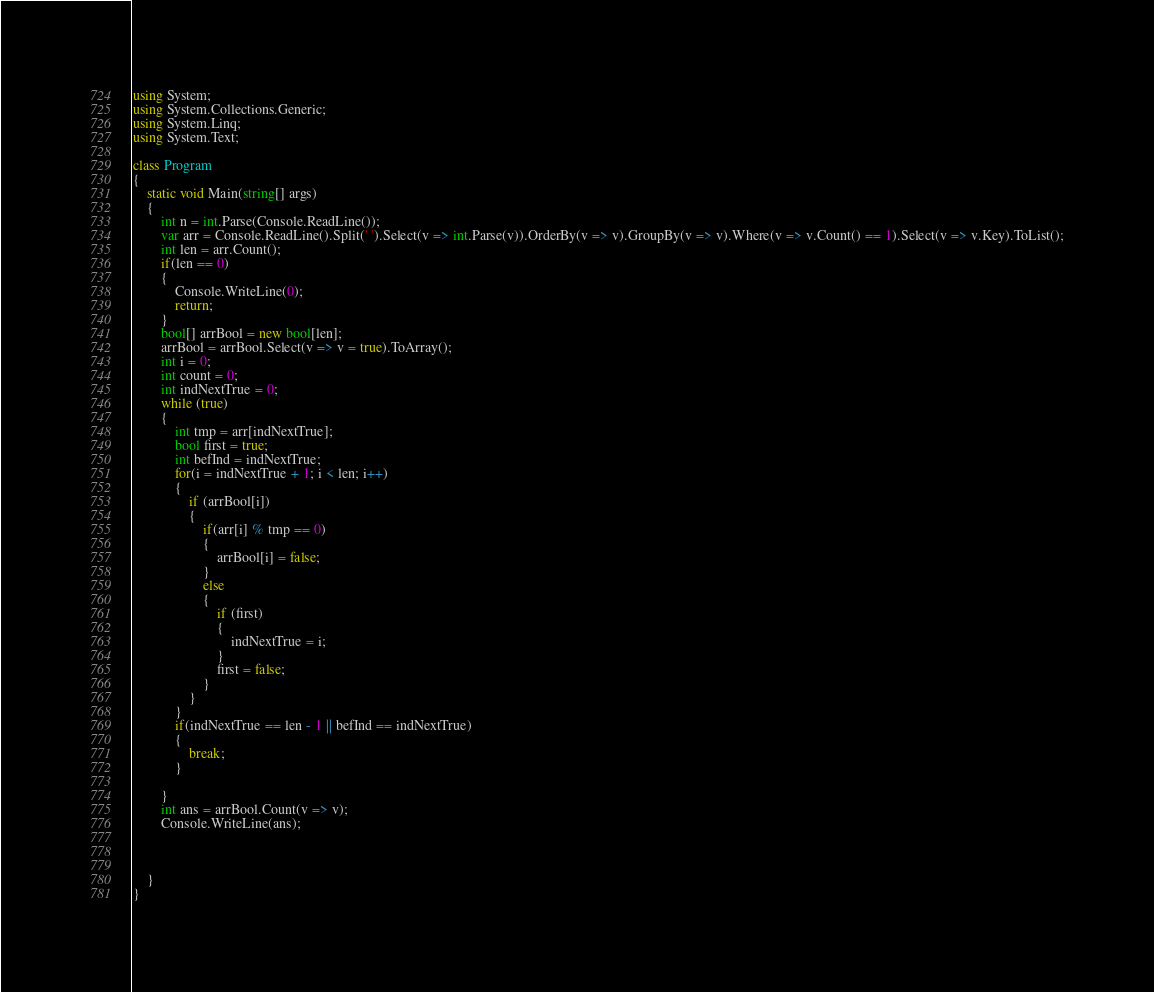<code> <loc_0><loc_0><loc_500><loc_500><_C#_>using System;
using System.Collections.Generic;
using System.Linq;
using System.Text;

class Program
{
    static void Main(string[] args)
    {
        int n = int.Parse(Console.ReadLine());
        var arr = Console.ReadLine().Split(' ').Select(v => int.Parse(v)).OrderBy(v => v).GroupBy(v => v).Where(v => v.Count() == 1).Select(v => v.Key).ToList();
        int len = arr.Count();
        if(len == 0)
        {
            Console.WriteLine(0);
            return;
        }
        bool[] arrBool = new bool[len];
        arrBool = arrBool.Select(v => v = true).ToArray();
        int i = 0;
        int count = 0;
        int indNextTrue = 0;
        while (true)
        {
            int tmp = arr[indNextTrue];
            bool first = true;
            int befInd = indNextTrue;
            for(i = indNextTrue + 1; i < len; i++)
            {
                if (arrBool[i])
                {
                    if(arr[i] % tmp == 0)
                    {
                        arrBool[i] = false;
                    }
                    else
                    {
                        if (first)
                        {
                            indNextTrue = i;
                        }
                        first = false;
                    }
                }
            }
            if(indNextTrue == len - 1 || befInd == indNextTrue)
            {
                break;
            }
           
        }
        int ans = arrBool.Count(v => v);
        Console.WriteLine(ans);



    }
}</code> 